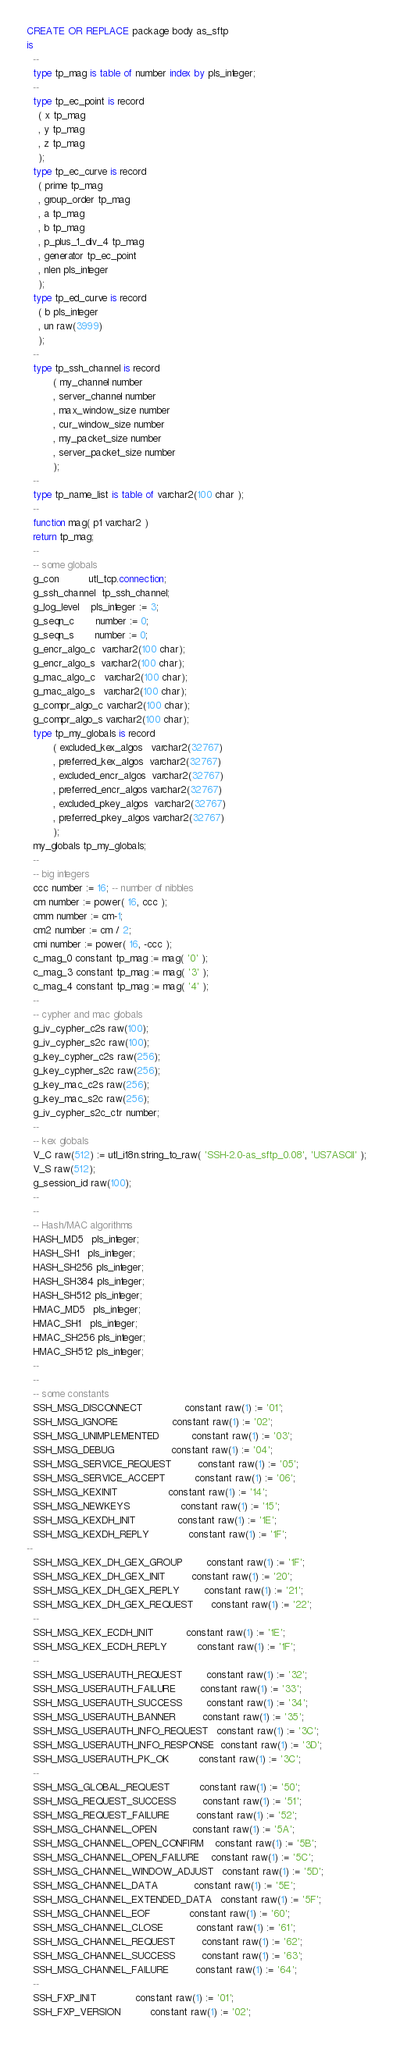Convert code to text. <code><loc_0><loc_0><loc_500><loc_500><_SQL_>CREATE OR REPLACE package body as_sftp
is
  --
  type tp_mag is table of number index by pls_integer;
  --
  type tp_ec_point is record
    ( x tp_mag
    , y tp_mag
    , z tp_mag
    );
  type tp_ec_curve is record
    ( prime tp_mag
    , group_order tp_mag
    , a tp_mag
    , b tp_mag
    , p_plus_1_div_4 tp_mag
    , generator tp_ec_point
    , nlen pls_integer
    );
  type tp_ed_curve is record
    ( b pls_integer
    , un raw(3999)
    );
  --
  type tp_ssh_channel is record
         ( my_channel number
         , server_channel number
         , max_window_size number
         , cur_window_size number
         , my_packet_size number
         , server_packet_size number
         );
  --
  type tp_name_list is table of varchar2(100 char );
  --
  function mag( p1 varchar2 )
  return tp_mag;
  --
  -- some globals
  g_con          utl_tcp.connection;
  g_ssh_channel  tp_ssh_channel;
  g_log_level    pls_integer := 3;
  g_seqn_c       number := 0;
  g_seqn_s       number := 0;
  g_encr_algo_c  varchar2(100 char);
  g_encr_algo_s  varchar2(100 char);
  g_mac_algo_c   varchar2(100 char);
  g_mac_algo_s   varchar2(100 char);
  g_compr_algo_c varchar2(100 char);
  g_compr_algo_s varchar2(100 char);
  type tp_my_globals is record
         ( excluded_kex_algos   varchar2(32767)
         , preferred_kex_algos  varchar2(32767)
         , excluded_encr_algos  varchar2(32767)
         , preferred_encr_algos varchar2(32767)
         , excluded_pkey_algos  varchar2(32767)
         , preferred_pkey_algos varchar2(32767)
         );
  my_globals tp_my_globals;
  --
  -- big integers
  ccc number := 16; -- number of nibbles
  cm number := power( 16, ccc );
  cmm number := cm-1;
  cm2 number := cm / 2;
  cmi number := power( 16, -ccc );
  c_mag_0 constant tp_mag := mag( '0' );  
  c_mag_3 constant tp_mag := mag( '3' );  
  c_mag_4 constant tp_mag := mag( '4' );  
  --
  -- cypher and mac globals
  g_iv_cypher_c2s raw(100);
  g_iv_cypher_s2c raw(100);
  g_key_cypher_c2s raw(256);
  g_key_cypher_s2c raw(256);
  g_key_mac_c2s raw(256);
  g_key_mac_s2c raw(256);
  g_iv_cypher_s2c_ctr number;
  --
  -- kex globals
  V_C raw(512) := utl_i18n.string_to_raw( 'SSH-2.0-as_sftp_0.08', 'US7ASCII' );
  V_S raw(512);
  g_session_id raw(100);
  --
  --
  -- Hash/MAC algorithms
  HASH_MD5   pls_integer;
  HASH_SH1   pls_integer;
  HASH_SH256 pls_integer;
  HASH_SH384 pls_integer;
  HASH_SH512 pls_integer;
  HMAC_MD5   pls_integer;
  HMAC_SH1   pls_integer;
  HMAC_SH256 pls_integer;
  HMAC_SH512 pls_integer;
  --
  --
  -- some constants
  SSH_MSG_DISCONNECT              constant raw(1) := '01';
  SSH_MSG_IGNORE                  constant raw(1) := '02';
  SSH_MSG_UNIMPLEMENTED           constant raw(1) := '03';
  SSH_MSG_DEBUG                   constant raw(1) := '04';
  SSH_MSG_SERVICE_REQUEST         constant raw(1) := '05';
  SSH_MSG_SERVICE_ACCEPT          constant raw(1) := '06';
  SSH_MSG_KEXINIT                 constant raw(1) := '14';
  SSH_MSG_NEWKEYS                 constant raw(1) := '15';
  SSH_MSG_KEXDH_INIT              constant raw(1) := '1E';
  SSH_MSG_KEXDH_REPLY             constant raw(1) := '1F';
--
  SSH_MSG_KEX_DH_GEX_GROUP        constant raw(1) := '1F';
  SSH_MSG_KEX_DH_GEX_INIT         constant raw(1) := '20';
  SSH_MSG_KEX_DH_GEX_REPLY        constant raw(1) := '21';
  SSH_MSG_KEX_DH_GEX_REQUEST      constant raw(1) := '22';
  --
  SSH_MSG_KEX_ECDH_INIT           constant raw(1) := '1E';
  SSH_MSG_KEX_ECDH_REPLY          constant raw(1) := '1F';
  --
  SSH_MSG_USERAUTH_REQUEST        constant raw(1) := '32';
  SSH_MSG_USERAUTH_FAILURE        constant raw(1) := '33';
  SSH_MSG_USERAUTH_SUCCESS        constant raw(1) := '34';
  SSH_MSG_USERAUTH_BANNER         constant raw(1) := '35';
  SSH_MSG_USERAUTH_INFO_REQUEST   constant raw(1) := '3C';
  SSH_MSG_USERAUTH_INFO_RESPONSE  constant raw(1) := '3D';
  SSH_MSG_USERAUTH_PK_OK          constant raw(1) := '3C';
  --
  SSH_MSG_GLOBAL_REQUEST          constant raw(1) := '50';
  SSH_MSG_REQUEST_SUCCESS         constant raw(1) := '51';
  SSH_MSG_REQUEST_FAILURE         constant raw(1) := '52';
  SSH_MSG_CHANNEL_OPEN            constant raw(1) := '5A';
  SSH_MSG_CHANNEL_OPEN_CONFIRM    constant raw(1) := '5B';
  SSH_MSG_CHANNEL_OPEN_FAILURE    constant raw(1) := '5C';
  SSH_MSG_CHANNEL_WINDOW_ADJUST   constant raw(1) := '5D';
  SSH_MSG_CHANNEL_DATA            constant raw(1) := '5E';
  SSH_MSG_CHANNEL_EXTENDED_DATA   constant raw(1) := '5F';
  SSH_MSG_CHANNEL_EOF             constant raw(1) := '60';
  SSH_MSG_CHANNEL_CLOSE           constant raw(1) := '61';
  SSH_MSG_CHANNEL_REQUEST         constant raw(1) := '62';
  SSH_MSG_CHANNEL_SUCCESS         constant raw(1) := '63';
  SSH_MSG_CHANNEL_FAILURE         constant raw(1) := '64';
  --
  SSH_FXP_INIT             constant raw(1) := '01';
  SSH_FXP_VERSION          constant raw(1) := '02';</code> 